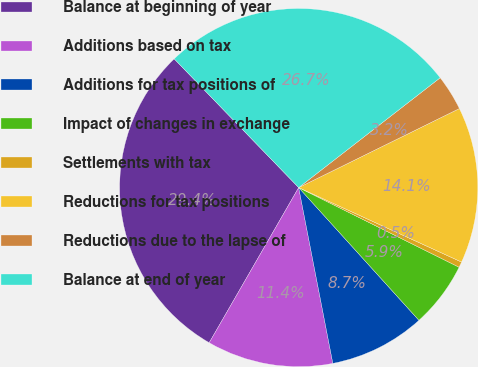Convert chart to OTSL. <chart><loc_0><loc_0><loc_500><loc_500><pie_chart><fcel>Balance at beginning of year<fcel>Additions based on tax<fcel>Additions for tax positions of<fcel>Impact of changes in exchange<fcel>Settlements with tax<fcel>Reductions for tax positions<fcel>Reductions due to the lapse of<fcel>Balance at end of year<nl><fcel>29.44%<fcel>11.38%<fcel>8.66%<fcel>5.95%<fcel>0.51%<fcel>14.1%<fcel>3.23%<fcel>26.73%<nl></chart> 